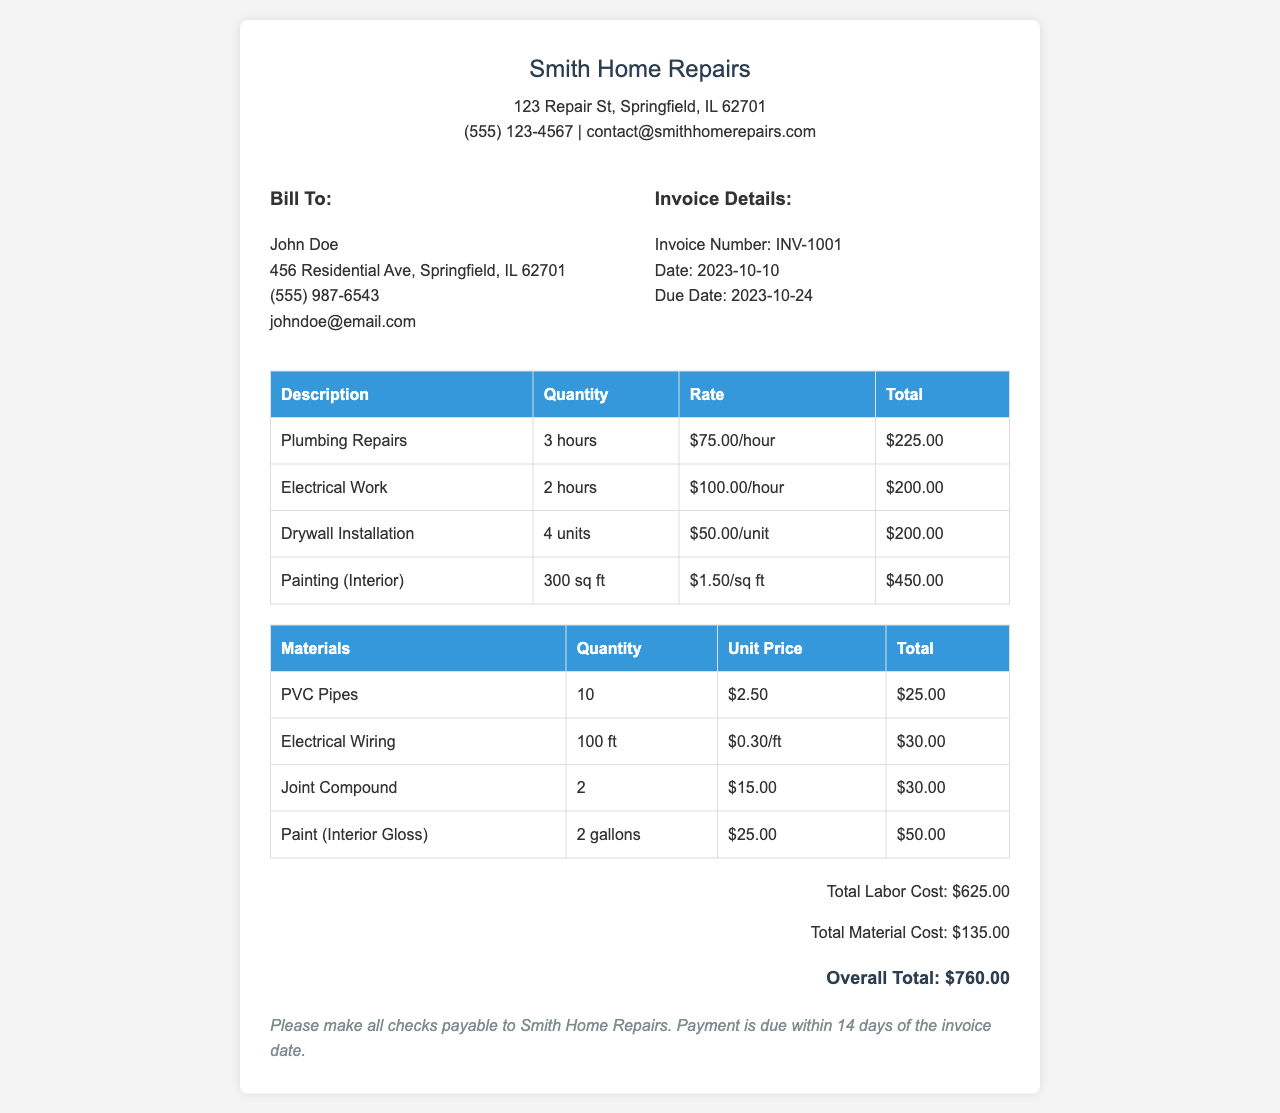What is the invoice number? The invoice number is stated under the invoice details section, listed as INV-1001.
Answer: INV-1001 What is the date of the invoice? The date is shown in the invoice details section next to the invoice number, which is 2023-10-10.
Answer: 2023-10-10 What is the total labor cost? The total labor cost is summarized at the bottom of the invoice, which is $625.00.
Answer: $625.00 How many hours were spent on plumbing repairs? The quantity for plumbing repairs is mentioned in the labor section as 3 hours.
Answer: 3 hours What materials were used for electrical work? In the materials section, Electrical Wiring is specified; it is indicated as one of the materials used.
Answer: Electrical Wiring What is the overall total cost? The overall total cost is the sum of labor and material costs, listed as $760.00 at the end of the invoice.
Answer: $760.00 When is payment due? Payment due date is mentioned in the payment instructions section, specified as within 14 days of the invoice date.
Answer: 14 days What is the unit price of PVC pipes? The unit price for PVC pipes is detailed under the materials section, which is $2.50.
Answer: $2.50 Who is the invoice addressed to? The invoice has a section labeled "Bill To," showing the customer's name as John Doe.
Answer: John Doe 